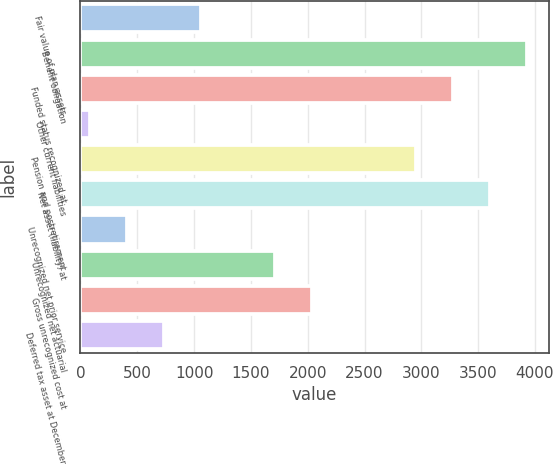<chart> <loc_0><loc_0><loc_500><loc_500><bar_chart><fcel>Fair value of plan assets<fcel>Benefit obligation<fcel>Funded status recognized at<fcel>Other current liabilities<fcel>Pension and postretirement<fcel>Net asset (liability) at<fcel>Unrecognized net prior service<fcel>Unrecognized net actuarial<fcel>Gross unrecognized cost at<fcel>Deferred tax asset at December<nl><fcel>1061.7<fcel>3925.7<fcel>3275.9<fcel>87<fcel>2951<fcel>3600.8<fcel>411.9<fcel>1711.5<fcel>2036.4<fcel>736.8<nl></chart> 